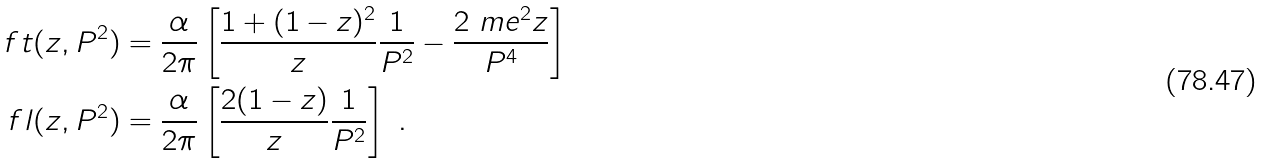<formula> <loc_0><loc_0><loc_500><loc_500>\ f t ( z , P ^ { 2 } ) & = \frac { \alpha } { 2 \pi } \left [ \frac { 1 + ( 1 - z ) ^ { 2 } } { z } \frac { 1 } { P ^ { 2 } } - \frac { 2 \ m e ^ { 2 } z } { P ^ { 4 } } \right ] \\ \ f l ( z , P ^ { 2 } ) & = \frac { \alpha } { 2 \pi } \left [ \frac { 2 ( 1 - z ) } { z } \frac { 1 } { P ^ { 2 } } \right ] \ .</formula> 